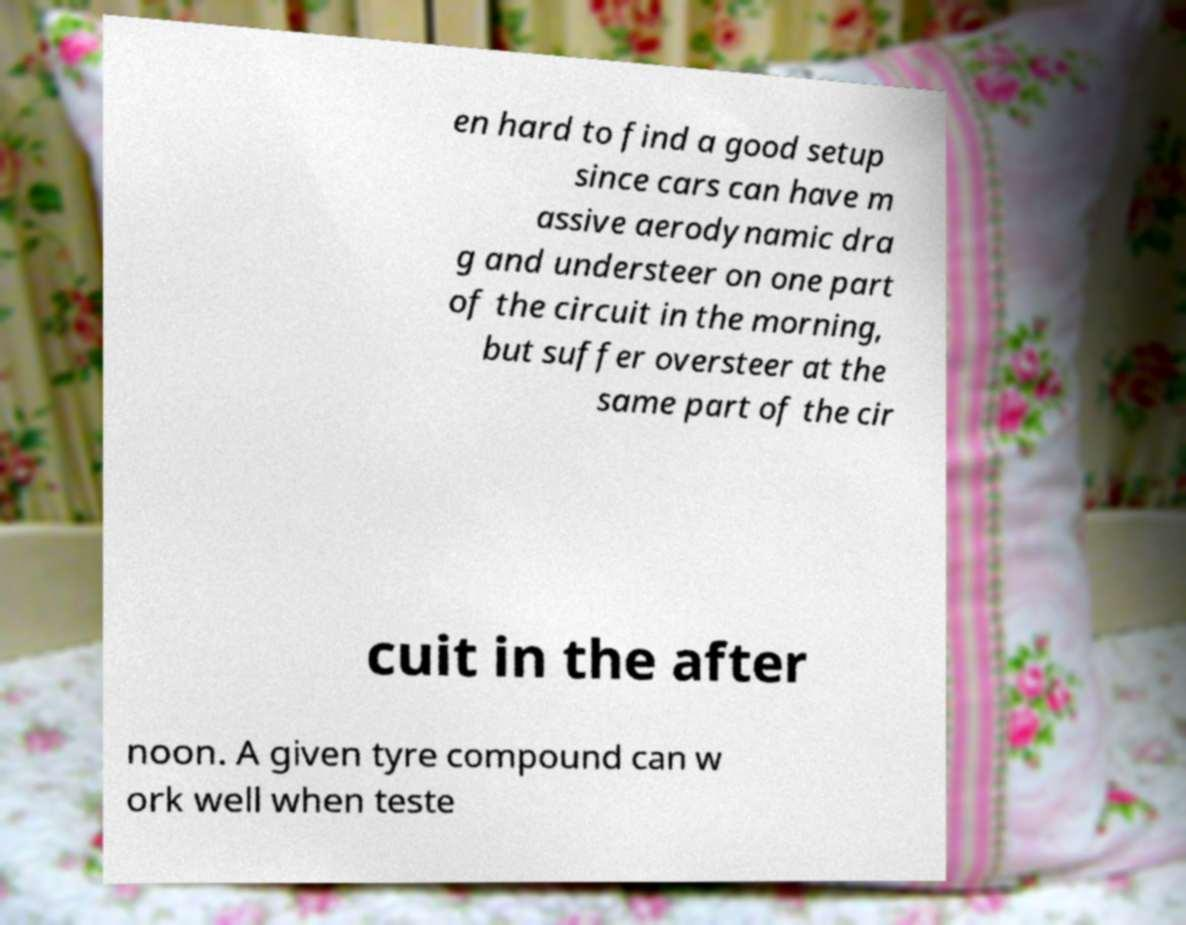Could you assist in decoding the text presented in this image and type it out clearly? en hard to find a good setup since cars can have m assive aerodynamic dra g and understeer on one part of the circuit in the morning, but suffer oversteer at the same part of the cir cuit in the after noon. A given tyre compound can w ork well when teste 